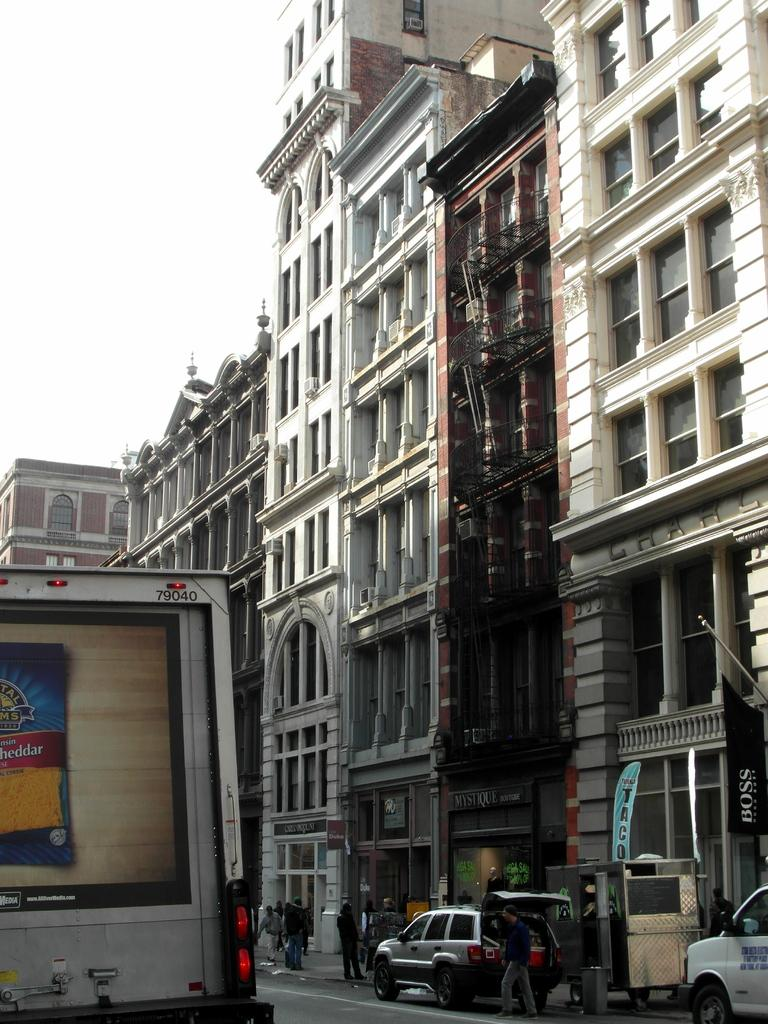What is the main structure in the image? There is a building in the image. Are there any vehicles near the building? Yes, there are two vehicles near the building. Are there any people present in the image? Yes, there are people standing near the building. What is visible at the top of the building? The sky is visible at the top of the building. What type of floor can be seen in the image? There is no specific floor mentioned or visible in the image; it only shows a building, vehicles, people, and the sky. 